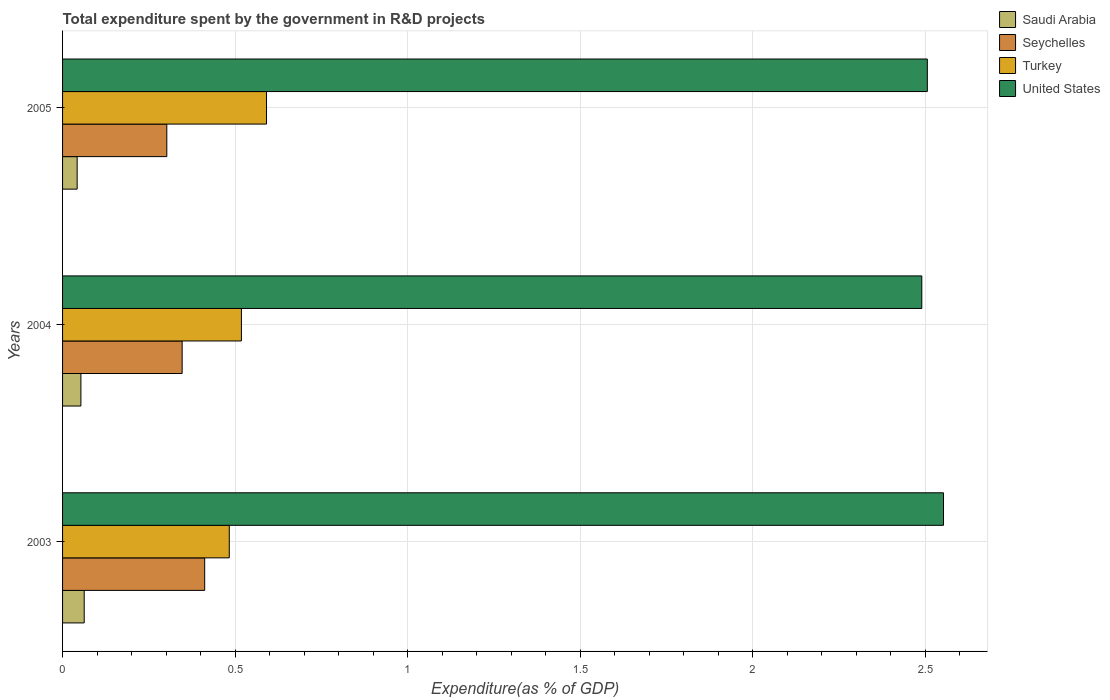How many different coloured bars are there?
Provide a short and direct response. 4. How many groups of bars are there?
Your answer should be very brief. 3. Are the number of bars per tick equal to the number of legend labels?
Provide a short and direct response. Yes. Are the number of bars on each tick of the Y-axis equal?
Your answer should be compact. Yes. How many bars are there on the 1st tick from the top?
Offer a very short reply. 4. What is the total expenditure spent by the government in R&D projects in Seychelles in 2005?
Offer a terse response. 0.3. Across all years, what is the maximum total expenditure spent by the government in R&D projects in Turkey?
Ensure brevity in your answer.  0.59. Across all years, what is the minimum total expenditure spent by the government in R&D projects in United States?
Your response must be concise. 2.49. What is the total total expenditure spent by the government in R&D projects in Turkey in the graph?
Your answer should be very brief. 1.59. What is the difference between the total expenditure spent by the government in R&D projects in Seychelles in 2003 and that in 2004?
Your response must be concise. 0.07. What is the difference between the total expenditure spent by the government in R&D projects in Saudi Arabia in 2004 and the total expenditure spent by the government in R&D projects in United States in 2003?
Offer a terse response. -2.5. What is the average total expenditure spent by the government in R&D projects in Saudi Arabia per year?
Provide a short and direct response. 0.05. In the year 2004, what is the difference between the total expenditure spent by the government in R&D projects in Seychelles and total expenditure spent by the government in R&D projects in Saudi Arabia?
Your answer should be very brief. 0.29. What is the ratio of the total expenditure spent by the government in R&D projects in United States in 2003 to that in 2004?
Offer a very short reply. 1.03. Is the difference between the total expenditure spent by the government in R&D projects in Seychelles in 2003 and 2005 greater than the difference between the total expenditure spent by the government in R&D projects in Saudi Arabia in 2003 and 2005?
Provide a succinct answer. Yes. What is the difference between the highest and the second highest total expenditure spent by the government in R&D projects in Turkey?
Your response must be concise. 0.07. What is the difference between the highest and the lowest total expenditure spent by the government in R&D projects in Saudi Arabia?
Make the answer very short. 0.02. In how many years, is the total expenditure spent by the government in R&D projects in Saudi Arabia greater than the average total expenditure spent by the government in R&D projects in Saudi Arabia taken over all years?
Offer a very short reply. 2. Is the sum of the total expenditure spent by the government in R&D projects in United States in 2004 and 2005 greater than the maximum total expenditure spent by the government in R&D projects in Seychelles across all years?
Your response must be concise. Yes. Is it the case that in every year, the sum of the total expenditure spent by the government in R&D projects in Seychelles and total expenditure spent by the government in R&D projects in Turkey is greater than the sum of total expenditure spent by the government in R&D projects in Saudi Arabia and total expenditure spent by the government in R&D projects in United States?
Give a very brief answer. Yes. What does the 4th bar from the top in 2004 represents?
Ensure brevity in your answer.  Saudi Arabia. What does the 4th bar from the bottom in 2003 represents?
Keep it short and to the point. United States. Is it the case that in every year, the sum of the total expenditure spent by the government in R&D projects in United States and total expenditure spent by the government in R&D projects in Saudi Arabia is greater than the total expenditure spent by the government in R&D projects in Seychelles?
Your answer should be compact. Yes. How many years are there in the graph?
Provide a short and direct response. 3. What is the difference between two consecutive major ticks on the X-axis?
Your response must be concise. 0.5. Does the graph contain grids?
Offer a very short reply. Yes. Where does the legend appear in the graph?
Provide a succinct answer. Top right. How many legend labels are there?
Your response must be concise. 4. How are the legend labels stacked?
Provide a succinct answer. Vertical. What is the title of the graph?
Give a very brief answer. Total expenditure spent by the government in R&D projects. Does "Denmark" appear as one of the legend labels in the graph?
Keep it short and to the point. No. What is the label or title of the X-axis?
Keep it short and to the point. Expenditure(as % of GDP). What is the Expenditure(as % of GDP) in Saudi Arabia in 2003?
Ensure brevity in your answer.  0.06. What is the Expenditure(as % of GDP) of Seychelles in 2003?
Make the answer very short. 0.41. What is the Expenditure(as % of GDP) of Turkey in 2003?
Your response must be concise. 0.48. What is the Expenditure(as % of GDP) in United States in 2003?
Your response must be concise. 2.55. What is the Expenditure(as % of GDP) in Saudi Arabia in 2004?
Give a very brief answer. 0.05. What is the Expenditure(as % of GDP) of Seychelles in 2004?
Offer a terse response. 0.35. What is the Expenditure(as % of GDP) in Turkey in 2004?
Offer a terse response. 0.52. What is the Expenditure(as % of GDP) in United States in 2004?
Give a very brief answer. 2.49. What is the Expenditure(as % of GDP) of Saudi Arabia in 2005?
Offer a terse response. 0.04. What is the Expenditure(as % of GDP) of Seychelles in 2005?
Ensure brevity in your answer.  0.3. What is the Expenditure(as % of GDP) of Turkey in 2005?
Your answer should be compact. 0.59. What is the Expenditure(as % of GDP) of United States in 2005?
Your answer should be very brief. 2.51. Across all years, what is the maximum Expenditure(as % of GDP) in Saudi Arabia?
Your answer should be compact. 0.06. Across all years, what is the maximum Expenditure(as % of GDP) in Seychelles?
Give a very brief answer. 0.41. Across all years, what is the maximum Expenditure(as % of GDP) of Turkey?
Keep it short and to the point. 0.59. Across all years, what is the maximum Expenditure(as % of GDP) in United States?
Your answer should be very brief. 2.55. Across all years, what is the minimum Expenditure(as % of GDP) of Saudi Arabia?
Give a very brief answer. 0.04. Across all years, what is the minimum Expenditure(as % of GDP) in Seychelles?
Offer a very short reply. 0.3. Across all years, what is the minimum Expenditure(as % of GDP) in Turkey?
Provide a short and direct response. 0.48. Across all years, what is the minimum Expenditure(as % of GDP) in United States?
Offer a terse response. 2.49. What is the total Expenditure(as % of GDP) in Saudi Arabia in the graph?
Your answer should be very brief. 0.16. What is the total Expenditure(as % of GDP) in Seychelles in the graph?
Offer a terse response. 1.06. What is the total Expenditure(as % of GDP) of Turkey in the graph?
Keep it short and to the point. 1.59. What is the total Expenditure(as % of GDP) of United States in the graph?
Ensure brevity in your answer.  7.55. What is the difference between the Expenditure(as % of GDP) of Saudi Arabia in 2003 and that in 2004?
Make the answer very short. 0.01. What is the difference between the Expenditure(as % of GDP) of Seychelles in 2003 and that in 2004?
Ensure brevity in your answer.  0.07. What is the difference between the Expenditure(as % of GDP) of Turkey in 2003 and that in 2004?
Your answer should be very brief. -0.04. What is the difference between the Expenditure(as % of GDP) of United States in 2003 and that in 2004?
Your answer should be compact. 0.06. What is the difference between the Expenditure(as % of GDP) in Saudi Arabia in 2003 and that in 2005?
Offer a very short reply. 0.02. What is the difference between the Expenditure(as % of GDP) of Seychelles in 2003 and that in 2005?
Provide a short and direct response. 0.11. What is the difference between the Expenditure(as % of GDP) in Turkey in 2003 and that in 2005?
Give a very brief answer. -0.11. What is the difference between the Expenditure(as % of GDP) in United States in 2003 and that in 2005?
Offer a very short reply. 0.05. What is the difference between the Expenditure(as % of GDP) of Saudi Arabia in 2004 and that in 2005?
Your answer should be very brief. 0.01. What is the difference between the Expenditure(as % of GDP) of Seychelles in 2004 and that in 2005?
Give a very brief answer. 0.04. What is the difference between the Expenditure(as % of GDP) of Turkey in 2004 and that in 2005?
Give a very brief answer. -0.07. What is the difference between the Expenditure(as % of GDP) in United States in 2004 and that in 2005?
Your answer should be very brief. -0.02. What is the difference between the Expenditure(as % of GDP) of Saudi Arabia in 2003 and the Expenditure(as % of GDP) of Seychelles in 2004?
Make the answer very short. -0.28. What is the difference between the Expenditure(as % of GDP) of Saudi Arabia in 2003 and the Expenditure(as % of GDP) of Turkey in 2004?
Ensure brevity in your answer.  -0.46. What is the difference between the Expenditure(as % of GDP) of Saudi Arabia in 2003 and the Expenditure(as % of GDP) of United States in 2004?
Keep it short and to the point. -2.43. What is the difference between the Expenditure(as % of GDP) in Seychelles in 2003 and the Expenditure(as % of GDP) in Turkey in 2004?
Provide a succinct answer. -0.11. What is the difference between the Expenditure(as % of GDP) in Seychelles in 2003 and the Expenditure(as % of GDP) in United States in 2004?
Make the answer very short. -2.08. What is the difference between the Expenditure(as % of GDP) in Turkey in 2003 and the Expenditure(as % of GDP) in United States in 2004?
Give a very brief answer. -2.01. What is the difference between the Expenditure(as % of GDP) in Saudi Arabia in 2003 and the Expenditure(as % of GDP) in Seychelles in 2005?
Provide a succinct answer. -0.24. What is the difference between the Expenditure(as % of GDP) in Saudi Arabia in 2003 and the Expenditure(as % of GDP) in Turkey in 2005?
Offer a terse response. -0.53. What is the difference between the Expenditure(as % of GDP) of Saudi Arabia in 2003 and the Expenditure(as % of GDP) of United States in 2005?
Make the answer very short. -2.44. What is the difference between the Expenditure(as % of GDP) of Seychelles in 2003 and the Expenditure(as % of GDP) of Turkey in 2005?
Provide a succinct answer. -0.18. What is the difference between the Expenditure(as % of GDP) in Seychelles in 2003 and the Expenditure(as % of GDP) in United States in 2005?
Provide a succinct answer. -2.09. What is the difference between the Expenditure(as % of GDP) of Turkey in 2003 and the Expenditure(as % of GDP) of United States in 2005?
Your answer should be compact. -2.02. What is the difference between the Expenditure(as % of GDP) of Saudi Arabia in 2004 and the Expenditure(as % of GDP) of Seychelles in 2005?
Make the answer very short. -0.25. What is the difference between the Expenditure(as % of GDP) in Saudi Arabia in 2004 and the Expenditure(as % of GDP) in Turkey in 2005?
Your response must be concise. -0.54. What is the difference between the Expenditure(as % of GDP) in Saudi Arabia in 2004 and the Expenditure(as % of GDP) in United States in 2005?
Keep it short and to the point. -2.45. What is the difference between the Expenditure(as % of GDP) of Seychelles in 2004 and the Expenditure(as % of GDP) of Turkey in 2005?
Offer a terse response. -0.24. What is the difference between the Expenditure(as % of GDP) in Seychelles in 2004 and the Expenditure(as % of GDP) in United States in 2005?
Make the answer very short. -2.16. What is the difference between the Expenditure(as % of GDP) in Turkey in 2004 and the Expenditure(as % of GDP) in United States in 2005?
Offer a terse response. -1.99. What is the average Expenditure(as % of GDP) of Saudi Arabia per year?
Provide a succinct answer. 0.05. What is the average Expenditure(as % of GDP) of Seychelles per year?
Provide a succinct answer. 0.35. What is the average Expenditure(as % of GDP) in Turkey per year?
Your answer should be very brief. 0.53. What is the average Expenditure(as % of GDP) in United States per year?
Provide a succinct answer. 2.52. In the year 2003, what is the difference between the Expenditure(as % of GDP) in Saudi Arabia and Expenditure(as % of GDP) in Seychelles?
Give a very brief answer. -0.35. In the year 2003, what is the difference between the Expenditure(as % of GDP) of Saudi Arabia and Expenditure(as % of GDP) of Turkey?
Offer a very short reply. -0.42. In the year 2003, what is the difference between the Expenditure(as % of GDP) of Saudi Arabia and Expenditure(as % of GDP) of United States?
Provide a short and direct response. -2.49. In the year 2003, what is the difference between the Expenditure(as % of GDP) of Seychelles and Expenditure(as % of GDP) of Turkey?
Offer a terse response. -0.07. In the year 2003, what is the difference between the Expenditure(as % of GDP) in Seychelles and Expenditure(as % of GDP) in United States?
Provide a succinct answer. -2.14. In the year 2003, what is the difference between the Expenditure(as % of GDP) in Turkey and Expenditure(as % of GDP) in United States?
Your answer should be compact. -2.07. In the year 2004, what is the difference between the Expenditure(as % of GDP) in Saudi Arabia and Expenditure(as % of GDP) in Seychelles?
Provide a short and direct response. -0.29. In the year 2004, what is the difference between the Expenditure(as % of GDP) in Saudi Arabia and Expenditure(as % of GDP) in Turkey?
Make the answer very short. -0.47. In the year 2004, what is the difference between the Expenditure(as % of GDP) of Saudi Arabia and Expenditure(as % of GDP) of United States?
Your response must be concise. -2.44. In the year 2004, what is the difference between the Expenditure(as % of GDP) in Seychelles and Expenditure(as % of GDP) in Turkey?
Your answer should be very brief. -0.17. In the year 2004, what is the difference between the Expenditure(as % of GDP) in Seychelles and Expenditure(as % of GDP) in United States?
Offer a terse response. -2.14. In the year 2004, what is the difference between the Expenditure(as % of GDP) of Turkey and Expenditure(as % of GDP) of United States?
Offer a terse response. -1.97. In the year 2005, what is the difference between the Expenditure(as % of GDP) of Saudi Arabia and Expenditure(as % of GDP) of Seychelles?
Make the answer very short. -0.26. In the year 2005, what is the difference between the Expenditure(as % of GDP) of Saudi Arabia and Expenditure(as % of GDP) of Turkey?
Provide a succinct answer. -0.55. In the year 2005, what is the difference between the Expenditure(as % of GDP) of Saudi Arabia and Expenditure(as % of GDP) of United States?
Your answer should be compact. -2.46. In the year 2005, what is the difference between the Expenditure(as % of GDP) of Seychelles and Expenditure(as % of GDP) of Turkey?
Give a very brief answer. -0.29. In the year 2005, what is the difference between the Expenditure(as % of GDP) of Seychelles and Expenditure(as % of GDP) of United States?
Your answer should be very brief. -2.2. In the year 2005, what is the difference between the Expenditure(as % of GDP) of Turkey and Expenditure(as % of GDP) of United States?
Make the answer very short. -1.92. What is the ratio of the Expenditure(as % of GDP) in Saudi Arabia in 2003 to that in 2004?
Your answer should be compact. 1.18. What is the ratio of the Expenditure(as % of GDP) of Seychelles in 2003 to that in 2004?
Ensure brevity in your answer.  1.19. What is the ratio of the Expenditure(as % of GDP) in Turkey in 2003 to that in 2004?
Provide a short and direct response. 0.93. What is the ratio of the Expenditure(as % of GDP) of United States in 2003 to that in 2004?
Your answer should be compact. 1.03. What is the ratio of the Expenditure(as % of GDP) in Saudi Arabia in 2003 to that in 2005?
Your answer should be compact. 1.48. What is the ratio of the Expenditure(as % of GDP) in Seychelles in 2003 to that in 2005?
Give a very brief answer. 1.36. What is the ratio of the Expenditure(as % of GDP) of Turkey in 2003 to that in 2005?
Your response must be concise. 0.82. What is the ratio of the Expenditure(as % of GDP) in United States in 2003 to that in 2005?
Give a very brief answer. 1.02. What is the ratio of the Expenditure(as % of GDP) of Saudi Arabia in 2004 to that in 2005?
Keep it short and to the point. 1.26. What is the ratio of the Expenditure(as % of GDP) of Seychelles in 2004 to that in 2005?
Keep it short and to the point. 1.15. What is the ratio of the Expenditure(as % of GDP) of Turkey in 2004 to that in 2005?
Give a very brief answer. 0.88. What is the difference between the highest and the second highest Expenditure(as % of GDP) of Saudi Arabia?
Make the answer very short. 0.01. What is the difference between the highest and the second highest Expenditure(as % of GDP) in Seychelles?
Make the answer very short. 0.07. What is the difference between the highest and the second highest Expenditure(as % of GDP) of Turkey?
Offer a very short reply. 0.07. What is the difference between the highest and the second highest Expenditure(as % of GDP) of United States?
Give a very brief answer. 0.05. What is the difference between the highest and the lowest Expenditure(as % of GDP) of Saudi Arabia?
Your answer should be very brief. 0.02. What is the difference between the highest and the lowest Expenditure(as % of GDP) in Seychelles?
Provide a succinct answer. 0.11. What is the difference between the highest and the lowest Expenditure(as % of GDP) in Turkey?
Give a very brief answer. 0.11. What is the difference between the highest and the lowest Expenditure(as % of GDP) in United States?
Provide a succinct answer. 0.06. 